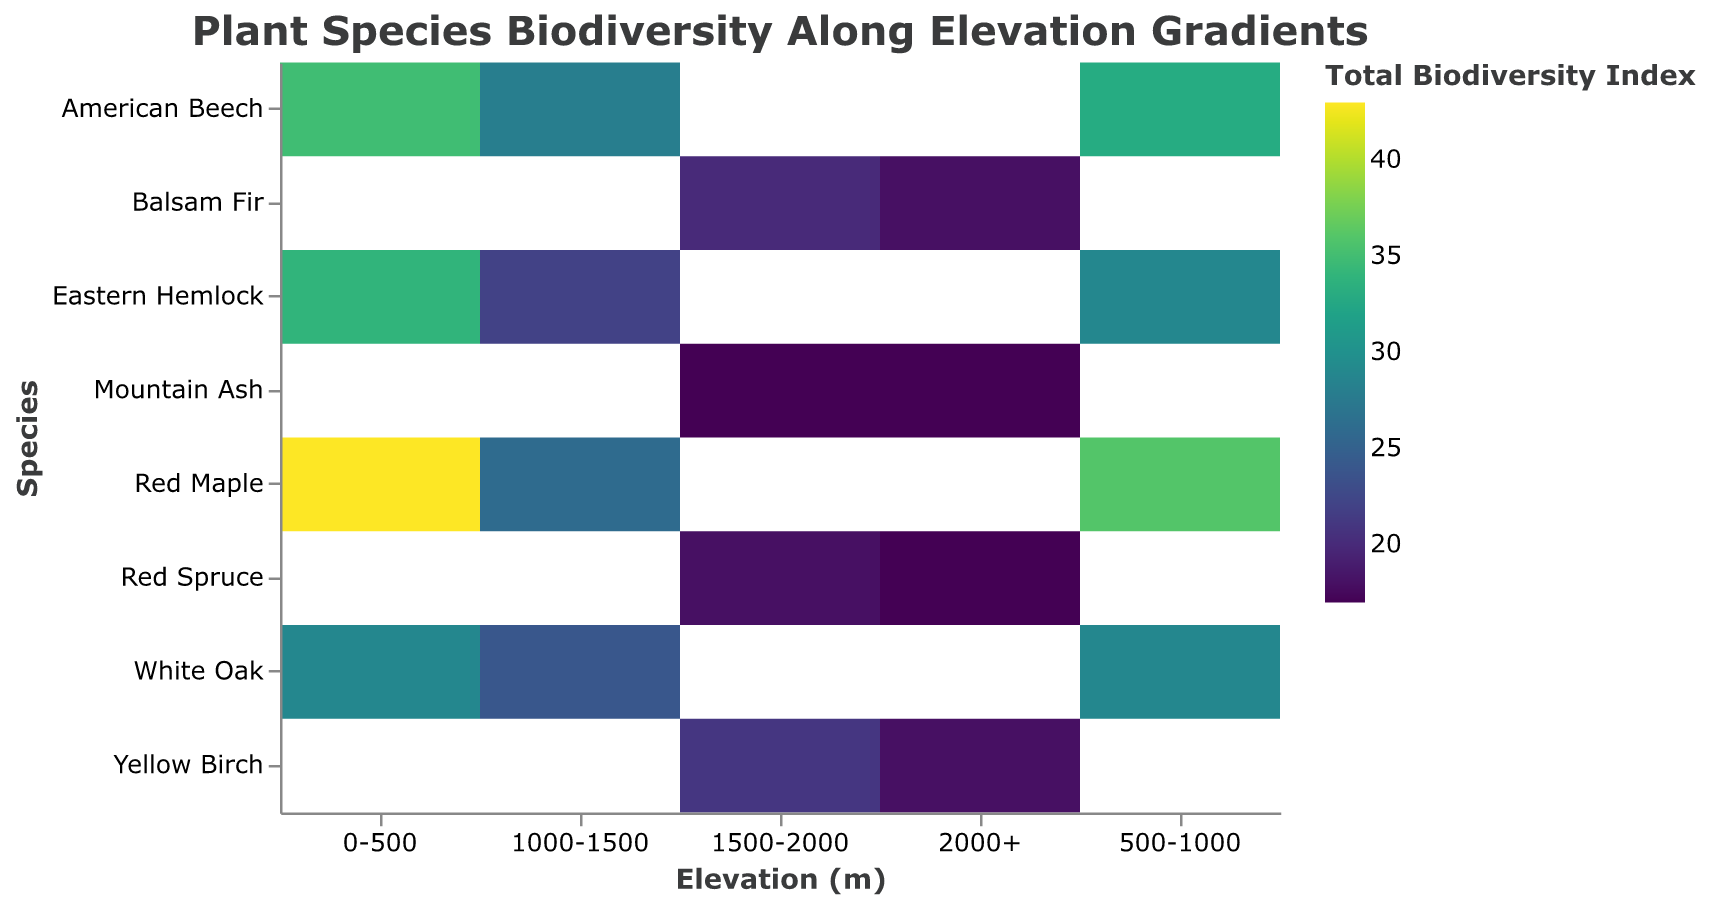What is the title of the heatmap? The title is located at the top of the figure and provides an overview of what the visual represents. It reads "Plant Species Biodiversity Along Elevation Gradients."
Answer: Plant Species Biodiversity Along Elevation Gradients Which elevation gradient has the highest biodiversity for Red Maple? Look at the color intensity in the row corresponding to "Red Maple." The cell for "0-500" has the most vibrant color on the heatmap.
Answer: 0-500 What is the Total Biodiversity Index for White Oak at 1000-1500 meters elevation? Locate the cell where the "Species" is "White Oak" and the "Elevation (m)" is "1000-1500." The color legend indicates a Total Biodiversity Index of 24.
Answer: 24 Which species shows the most significant drop in Total Biodiversity Index as elevation increases from 0-500 to 1000-1500 meters? Compare the color intensities for each species from "0-500" to "1000-1500." Red Maple shows a considerable drop in color intensity from 43 to 26.
Answer: Red Maple What is the average Total Biodiversity Index for Eastern Hemlock across all elevations? Sum the values for Eastern Hemlock across all elevation gradients: 34 (0-500) + 29 (500-1000) + 22 (1000-1500). Divide by the number of elevations (3).
Answer: (34 + 29 + 22) / 3 = 85 / 3 = 28.33 Which elevation gradient has the lowest overall biodiversity index for all species combined? Sum the Total Biodiversity Index for each elevation gradient: 0-500: (35+43+29+34), 500-1000: (33+36+29+29), 1000-1500: (28+26+24+22), 1500-2000: (20+21+17+18), 2000+: (18+18+17+17). Identify the lowest sum.
Answer: 2000+ (18+18+17+17) = 70 Does American Beech have a higher Total Biodiversity Index at 500-1000 meters or 1000-1500 meters? Locate the cells corresponding to American Beech at each elevation and compare their values: 500-1000: 33, 1000-1500: 28.
Answer: 500-1000 What is the difference in the Total Biodiversity Index between the highest and lowest values for any species in the heatmap? Find the highest and lowest values in the color scale (highest: Red Maple at 0-500 with 43, lowest: Mountain Ash at 1500-2000 and 2000+ with 17). Subtract the lowest value from the highest value.
Answer: 43 - 17 = 26 Which species has a consistent Total Biodiversity Index across all elevation gradients? Observe each species' cells across the elevation levels to find consistent values. White Oak consistently shows 29 at both 0-500 and 500-1000 meters, but no species has consistent indices across all elevations.
Answer: None 